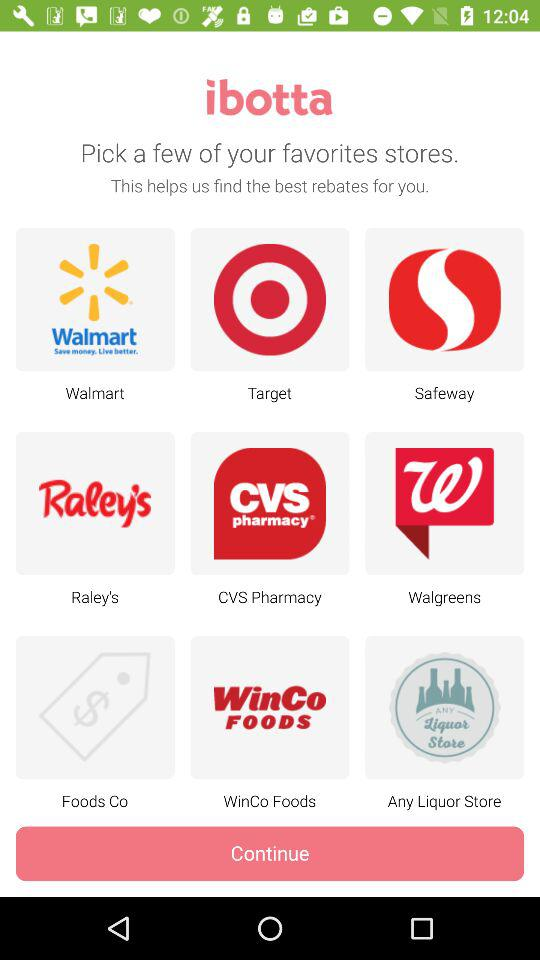Which stores have the best rebates?
When the provided information is insufficient, respond with <no answer>. <no answer> 